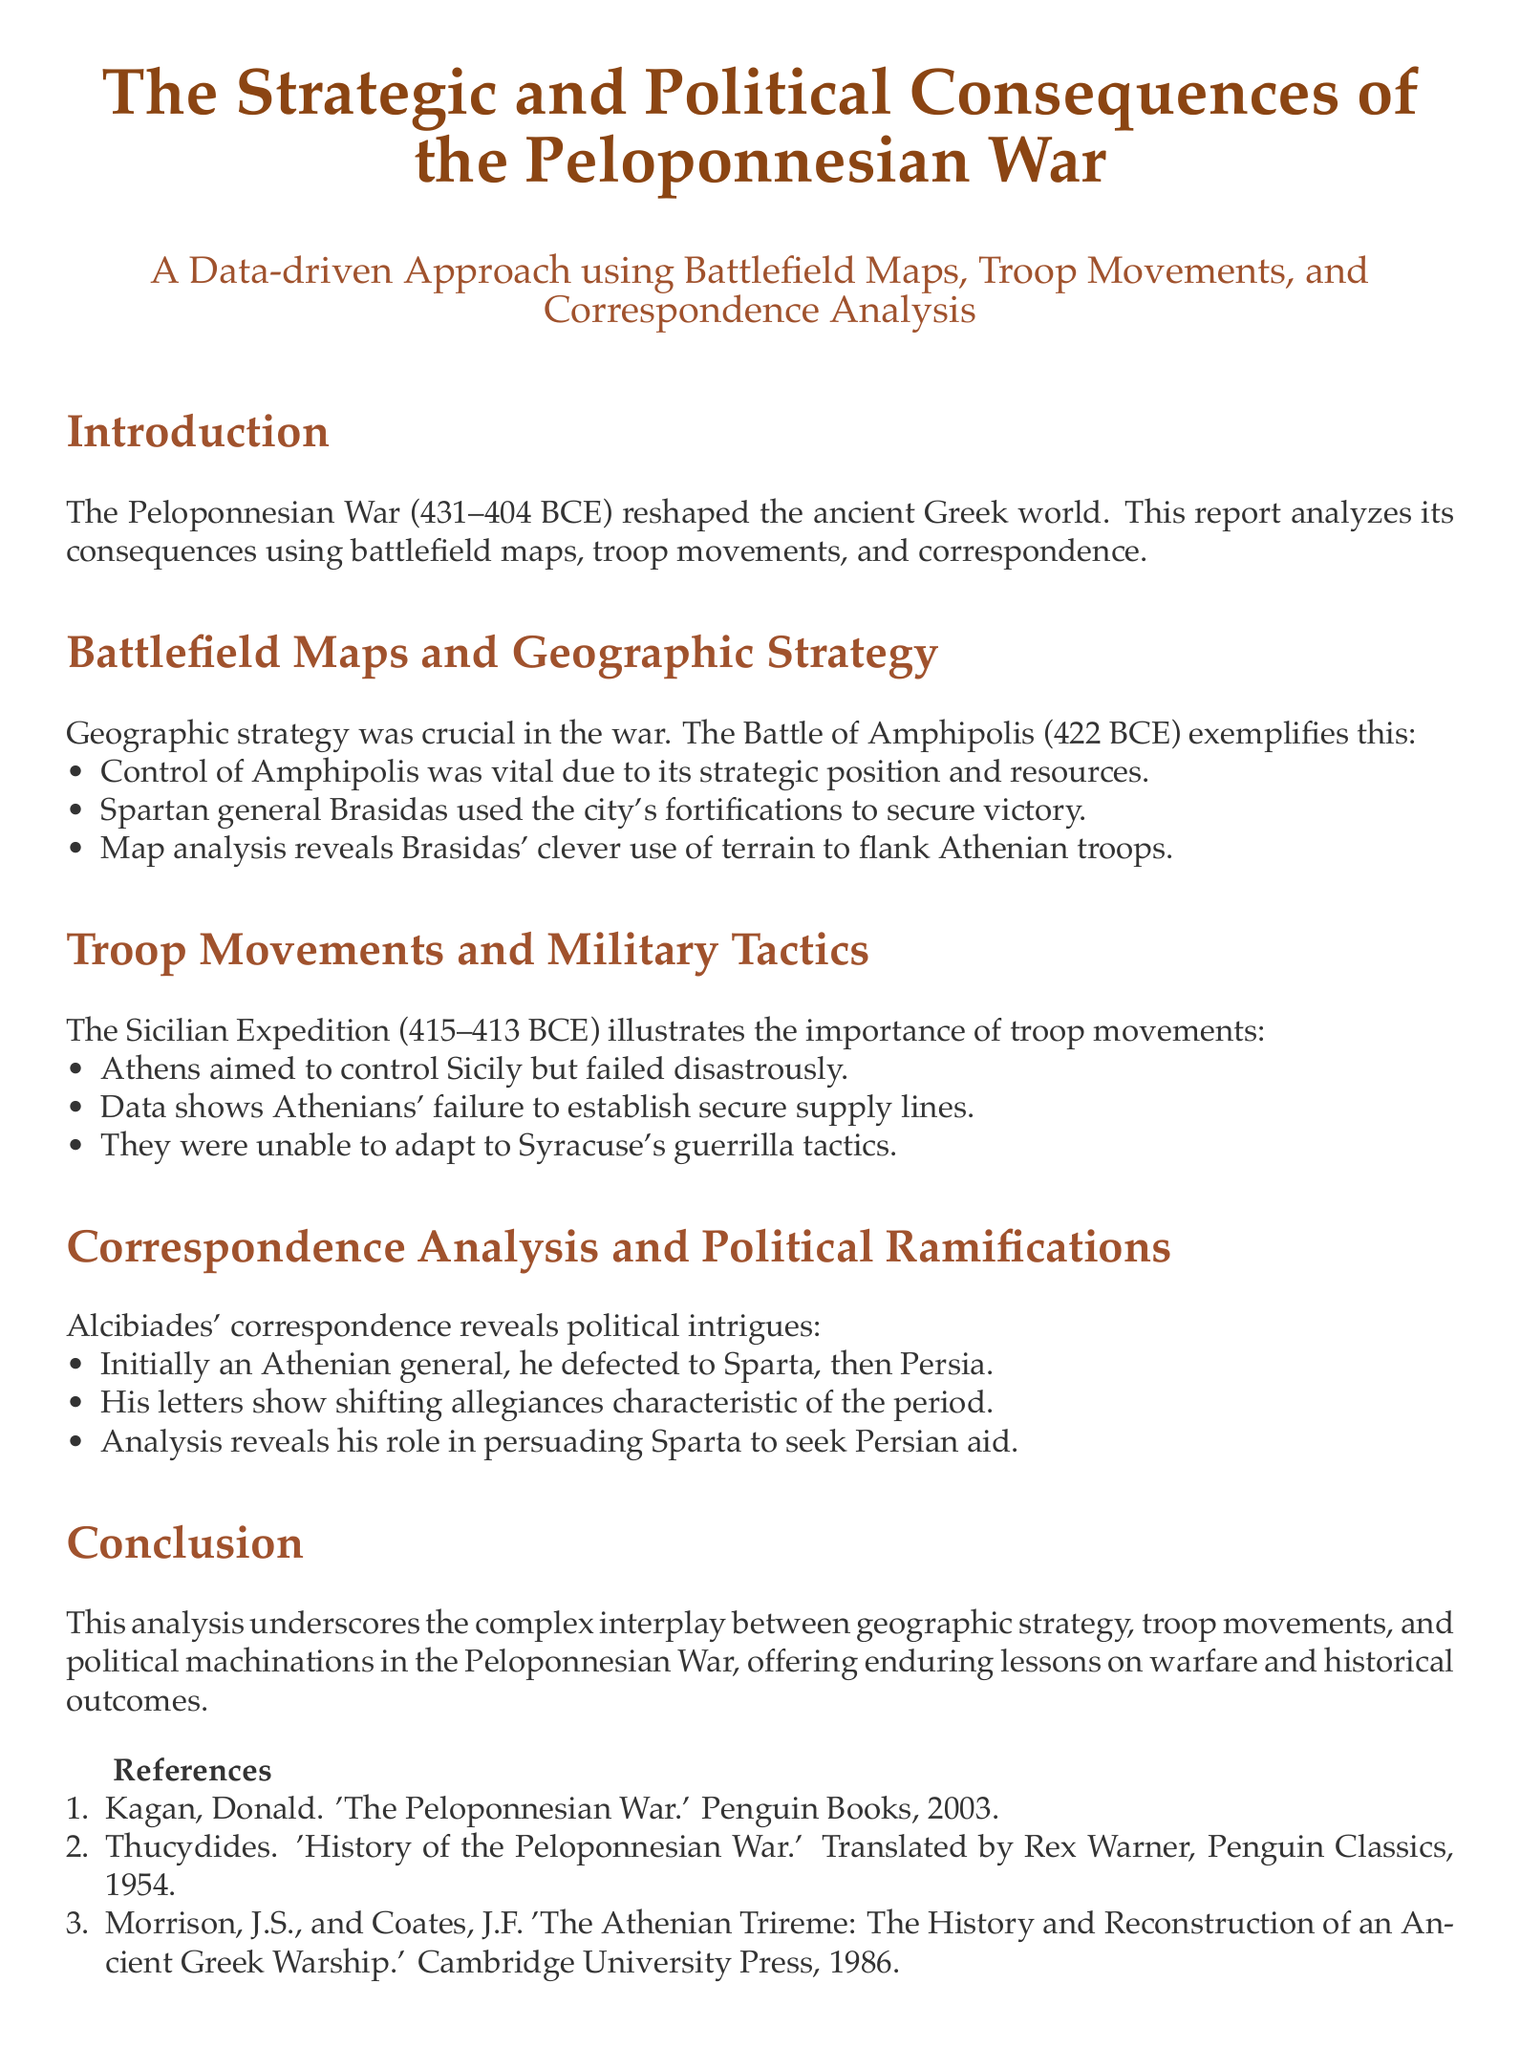What was the duration of the Peloponnesian War? The document states the Peloponnesian War lasted from 431 to 404 BCE.
Answer: 431–404 BCE Which battle is highlighted in the section on geographic strategy? The section references the Battle of Amphipolis as an example of geographic strategy.
Answer: Battle of Amphipolis What was a significant factor in Athens' failure during the Sicilian Expedition? The text mentions that Athenians failed to establish secure supply lines as a key factor in their failure.
Answer: Secure supply lines Who initially was Alcibiades before defecting? The document states that Alcibiades was an Athenian general initially.
Answer: Athenian general What does the correspondence analysis reveal about Alcibiades? The document points out that his letters show shifting allegiances characteristic of the period.
Answer: Shifting allegiances Which strategic position did Brasidas utilize in the Battle of Amphipolis? The report mentions that Brasidas used the city's fortifications to secure victory.
Answer: City's fortifications What was one of the military tactics associated with the Sicilian Expedition? The document indicates that the Athenians were unable to adapt to Syracuse's guerrilla tactics.
Answer: Guerrilla tactics What type of analysis is employed to understand the political ramifications of the war? The document specifies that correspondence analysis is used for political ramifications.
Answer: Correspondence analysis 